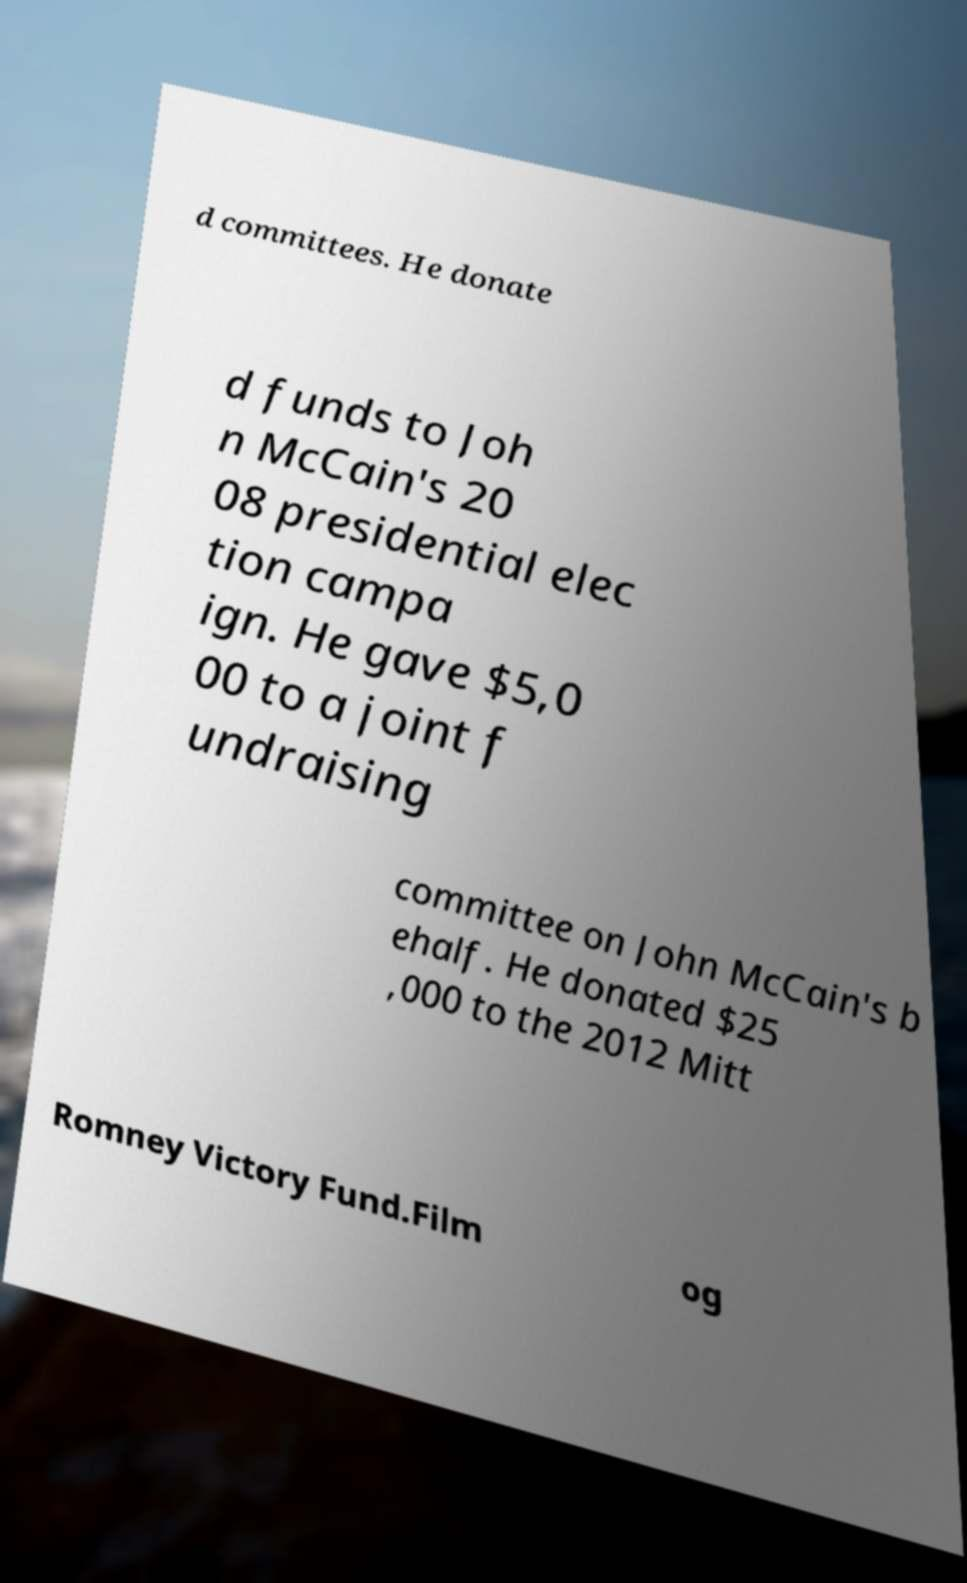For documentation purposes, I need the text within this image transcribed. Could you provide that? d committees. He donate d funds to Joh n McCain's 20 08 presidential elec tion campa ign. He gave $5,0 00 to a joint f undraising committee on John McCain's b ehalf. He donated $25 ,000 to the 2012 Mitt Romney Victory Fund.Film og 